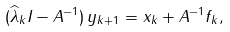<formula> <loc_0><loc_0><loc_500><loc_500>( \widehat { \lambda } _ { k } I - A ^ { - 1 } ) \, y _ { k + 1 } = x _ { k } + A ^ { - 1 } f _ { k } ,</formula> 